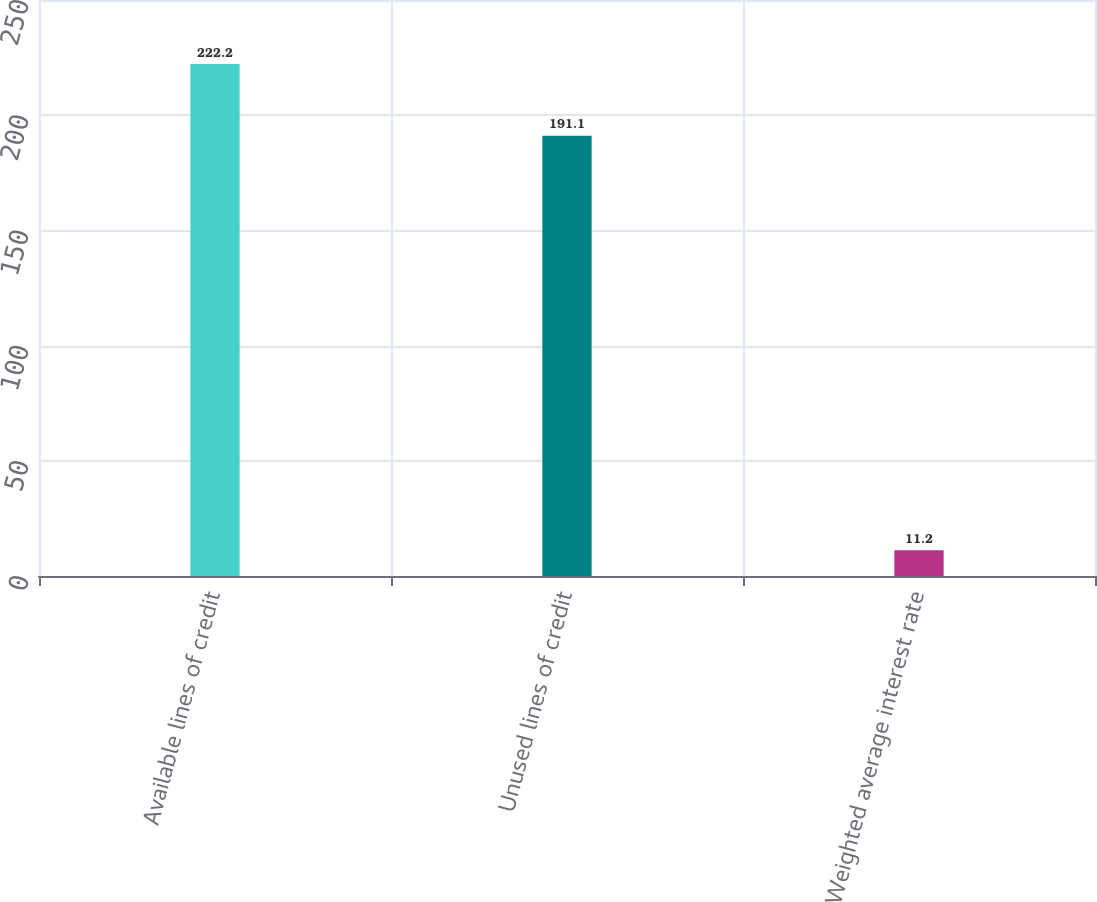<chart> <loc_0><loc_0><loc_500><loc_500><bar_chart><fcel>Available lines of credit<fcel>Unused lines of credit<fcel>Weighted average interest rate<nl><fcel>222.2<fcel>191.1<fcel>11.2<nl></chart> 